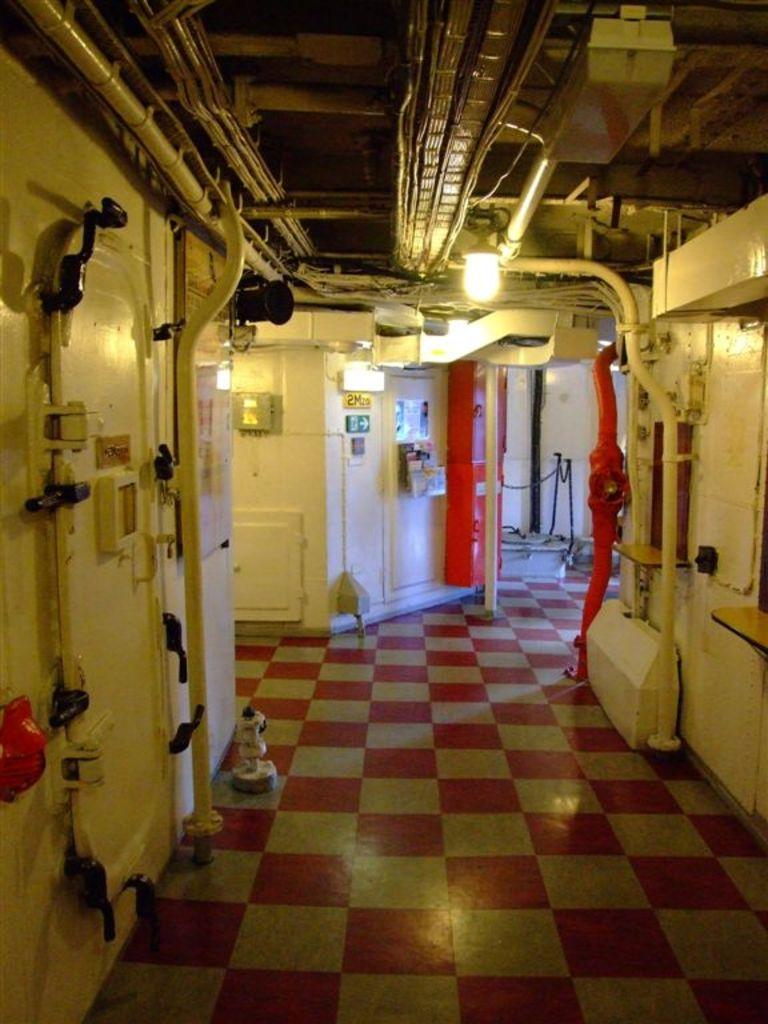What is attached to the wall in the image? There are pipes attached to the wall in the image. What is attached to the roof in the image? There is a light attached to the roof in the image. Are the pipes connected to the light in any way? Yes, the light has pipes connected to it. What is on the floor in the image? There is an object on the floor in the image. How does the secretary use the flame to complete their tasks in the image? There is no secretary or flame present in the image. What type of paste is used to attach the pipes to the wall in the image? There is no mention of paste being used to attach the pipes to the wall in the image. 